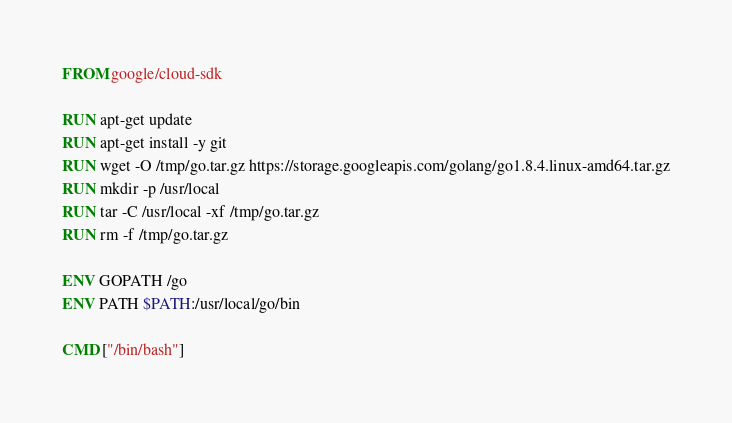Convert code to text. <code><loc_0><loc_0><loc_500><loc_500><_Dockerfile_>FROM google/cloud-sdk

RUN apt-get update
RUN apt-get install -y git
RUN wget -O /tmp/go.tar.gz https://storage.googleapis.com/golang/go1.8.4.linux-amd64.tar.gz
RUN mkdir -p /usr/local
RUN tar -C /usr/local -xf /tmp/go.tar.gz
RUN rm -f /tmp/go.tar.gz

ENV GOPATH /go
ENV PATH $PATH:/usr/local/go/bin

CMD ["/bin/bash"]
</code> 